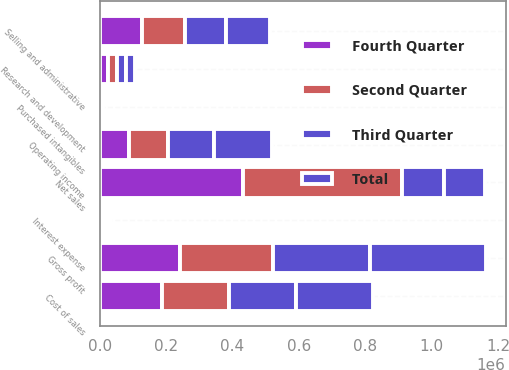<chart> <loc_0><loc_0><loc_500><loc_500><stacked_bar_chart><ecel><fcel>Net sales<fcel>Cost of sales<fcel>Gross profit<fcel>Selling and administrative<fcel>Research and development<fcel>Purchased intangibles<fcel>Operating income<fcel>Interest expense<nl><fcel>Fourth Quarter<fcel>430508<fcel>187719<fcel>242789<fcel>126635<fcel>24746<fcel>2647<fcel>88761<fcel>7489<nl><fcel>Second Quarter<fcel>481801<fcel>201853<fcel>279948<fcel>131930<fcel>26977<fcel>2646<fcel>118395<fcel>7971<nl><fcel>Third Quarter<fcel>124430<fcel>202222<fcel>290943<fcel>122226<fcel>27279<fcel>2725<fcel>138713<fcel>9062<nl><fcel>Total<fcel>124430<fcel>233119<fcel>350751<fcel>131916<fcel>28724<fcel>2616<fcel>172039<fcel>9669<nl></chart> 